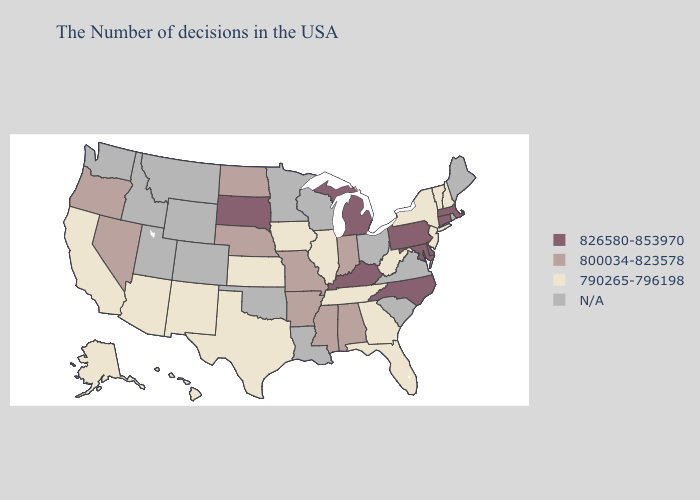Among the states that border Kansas , which have the highest value?
Short answer required. Missouri, Nebraska. Among the states that border Minnesota , does South Dakota have the lowest value?
Concise answer only. No. What is the value of Wisconsin?
Answer briefly. N/A. Among the states that border Tennessee , which have the highest value?
Keep it brief. North Carolina, Kentucky. What is the highest value in the Northeast ?
Give a very brief answer. 826580-853970. What is the value of South Carolina?
Answer briefly. N/A. Does New Jersey have the lowest value in the USA?
Answer briefly. Yes. What is the value of North Dakota?
Short answer required. 800034-823578. Among the states that border Kansas , which have the highest value?
Short answer required. Missouri, Nebraska. Name the states that have a value in the range 800034-823578?
Quick response, please. Indiana, Alabama, Mississippi, Missouri, Arkansas, Nebraska, North Dakota, Nevada, Oregon. Name the states that have a value in the range 826580-853970?
Keep it brief. Massachusetts, Connecticut, Delaware, Maryland, Pennsylvania, North Carolina, Michigan, Kentucky, South Dakota. Which states hav the highest value in the West?
Answer briefly. Nevada, Oregon. 